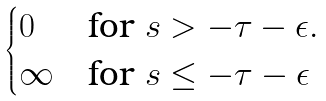<formula> <loc_0><loc_0><loc_500><loc_500>\begin{cases} 0 & \text {for $s>-\tau-\epsilon.$ } \\ \infty & \text {for $s\leq-\tau-\epsilon$} \end{cases}</formula> 